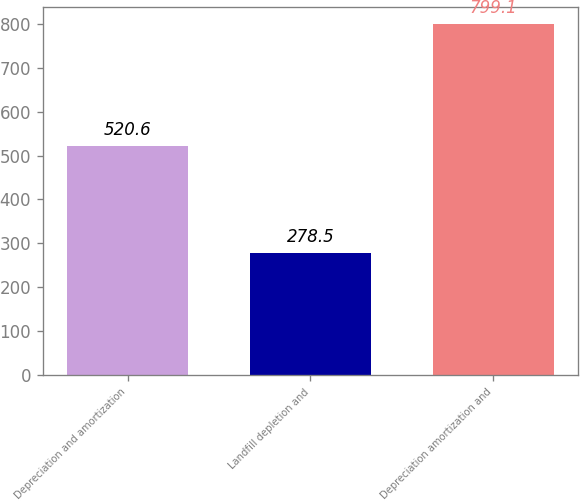Convert chart to OTSL. <chart><loc_0><loc_0><loc_500><loc_500><bar_chart><fcel>Depreciation and amortization<fcel>Landfill depletion and<fcel>Depreciation amortization and<nl><fcel>520.6<fcel>278.5<fcel>799.1<nl></chart> 